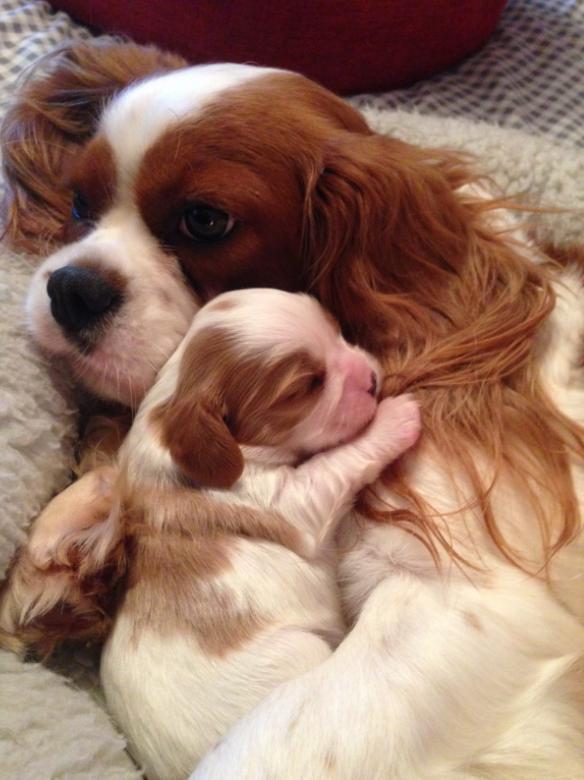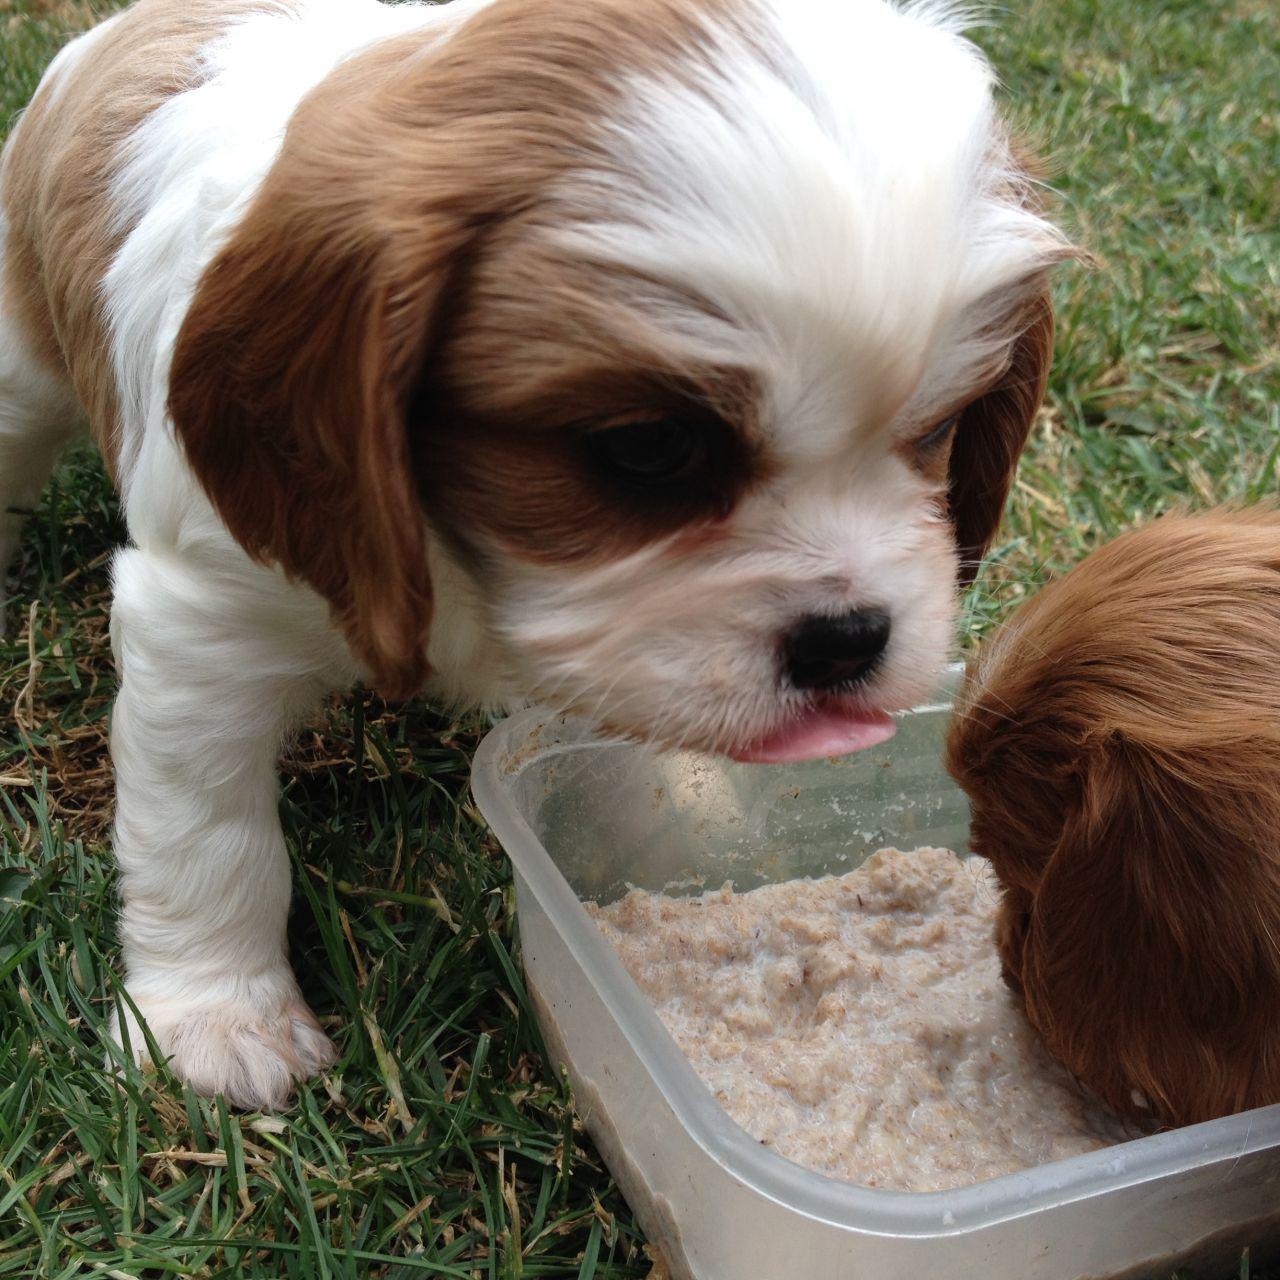The first image is the image on the left, the second image is the image on the right. Analyze the images presented: Is the assertion "At least one King Charles puppy is shown next to their mother." valid? Answer yes or no. Yes. The first image is the image on the left, the second image is the image on the right. Assess this claim about the two images: "An image contains at least two dogs.". Correct or not? Answer yes or no. Yes. 